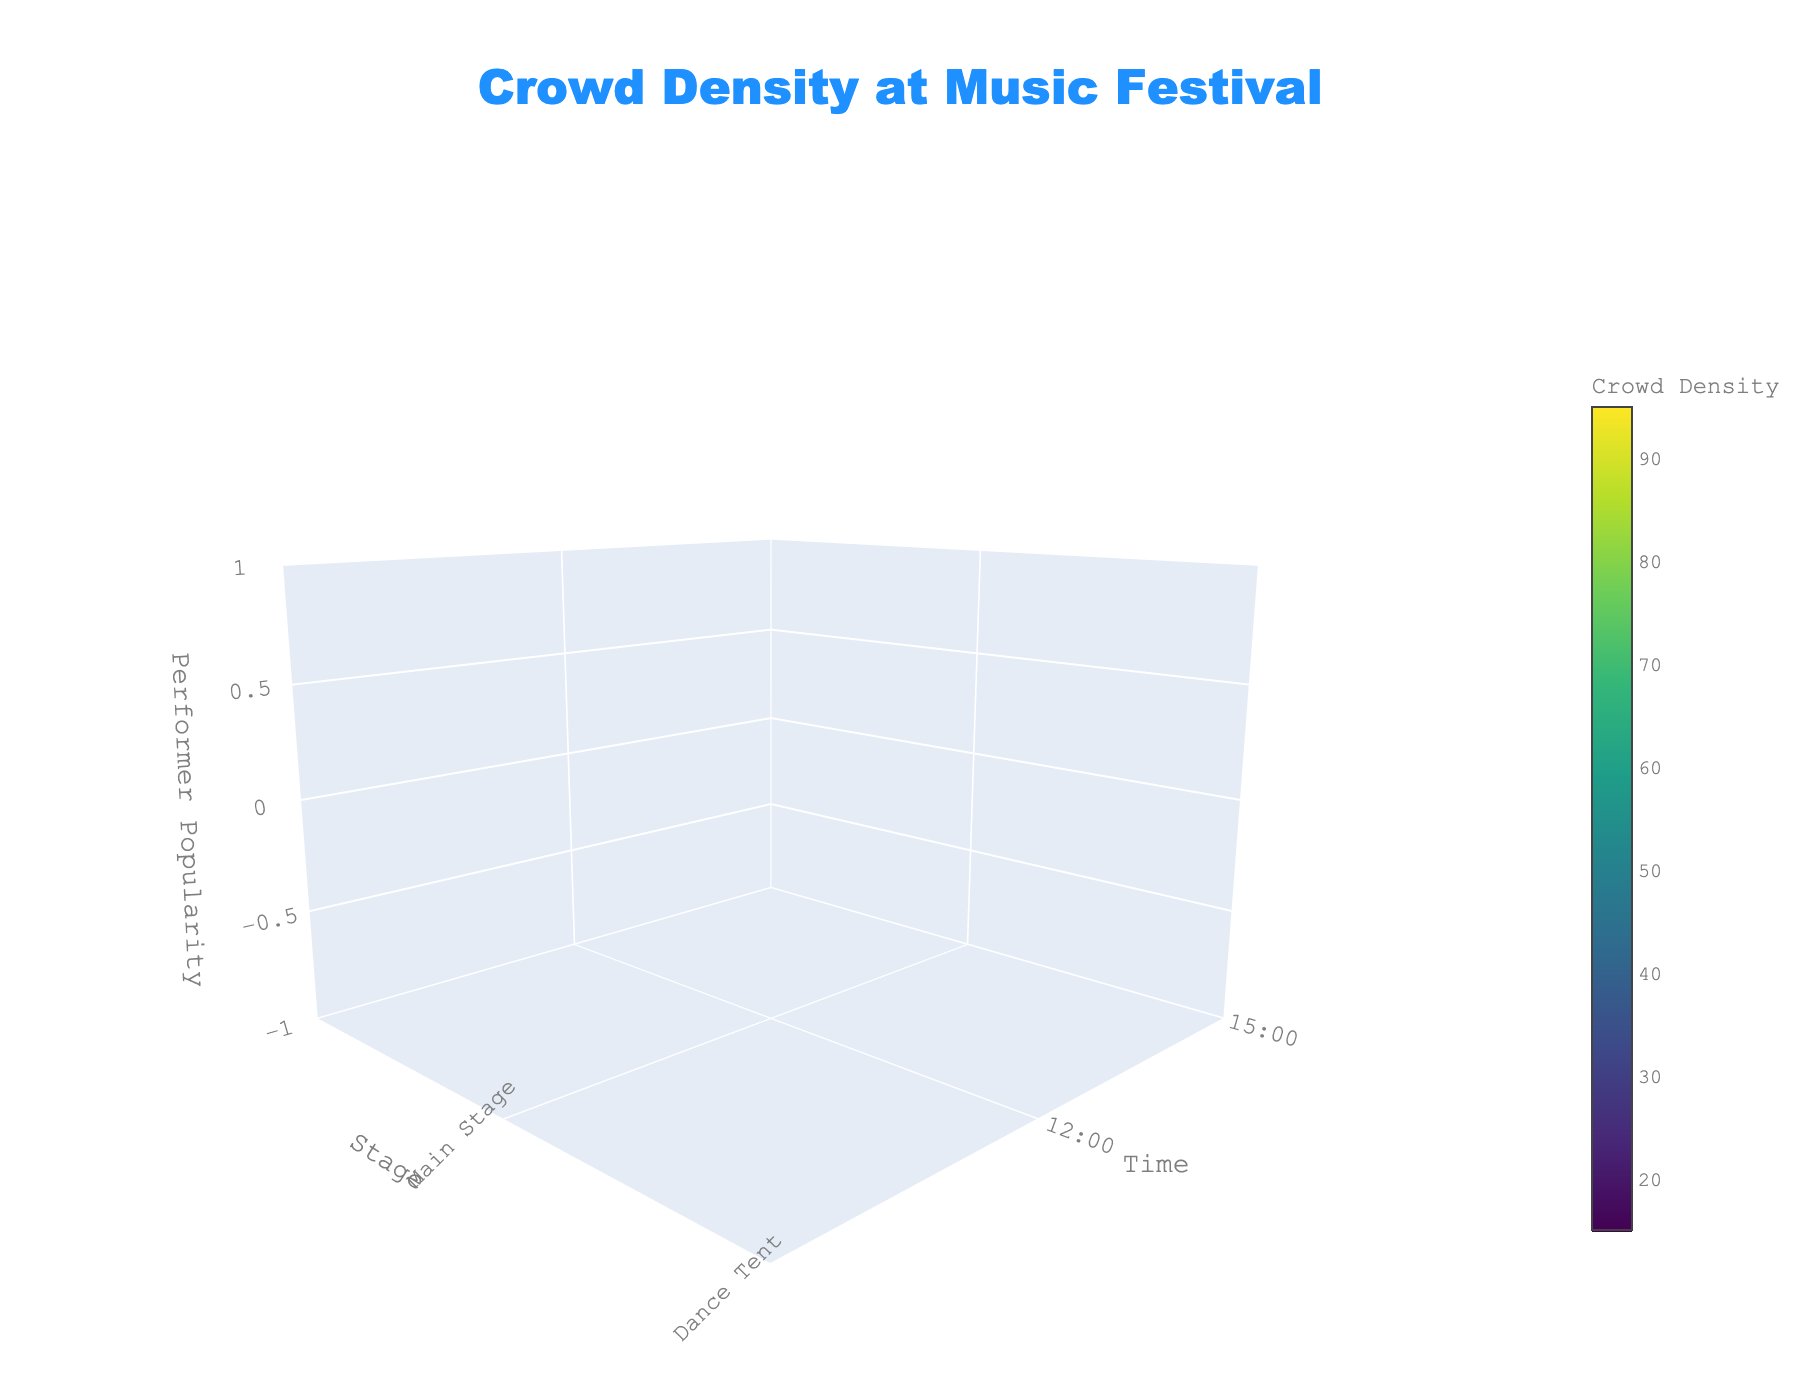What's the title of the figure? The title of the figure is displayed prominently at the top. It reads "Crowd Density at Music Festival"
Answer: Crowd Density at Music Festival Which axis represents the time of day? In the plot, the y-axis is labeled "Time," indicating that it represents the time of day.
Answer: y-axis What stage has the highest crowd density at 21:00? Observing the plot at 21:00 across different stages, the Main Stage has the highest crowd density value of 95.
Answer: Main Stage At what time does the Dance Tent have a crowd density of 70? By looking at the points representing the Dance Tent and finding where the crowd density is 70, we see that this occurs at 18:00.
Answer: 18:00 How does the crowd density at the Indie Stage at 12:00 compare to that at the Electronic Arena at the same time? The plot shows that at 12:00, the crowd density at the Indie Stage is 15, while at the Electronic Arena, it is 25. Therefore, the Indie Stage has a lower crowd density.
Answer: Indie Stage has lower density What is the average crowd density for performances at 15:00? To find this, look at the crowd densities at 15:00 across all stages: Main Stage (55), Dance Tent (45), Indie Stage (35), and Electronic Arena (50). The average is (55 + 45 + 35 + 50) / 4 = 46.25
Answer: 46.25 Which performer has the highest popularity but the lowest crowd density? By cross-referencing the points on the plot, the Electronic Arena at 21:00 has a performer popularity of 95 but a crowd density of 90, which is comparatively lower than the Main Stage's 95 at 21:00 having a crowd density of 95.
Answer: Electronic Arena How does crowd density change on the Main Stage from 12:00 to 21:00? Observing the points on the Main Stage, crowd density increases as time progresses: 12:00 (30), 15:00 (55), 18:00 (80), 21:00 (95).
Answer: Increases Which stage shows the least variation in crowd density over the day? Looking at the range of crowd densities for each stage: Main Stage (30-95), Dance Tent (20-85), Indie Stage (15-75), and Electronic Arena (25-90), Indie Stage has the least variation (60 units).
Answer: Indie Stage Which time slot generally attracts the most crowd density across all stages? By comparing crowd densities at each time slot across all stages, 21:00 consistently shows the highest densities.
Answer: 21:00 